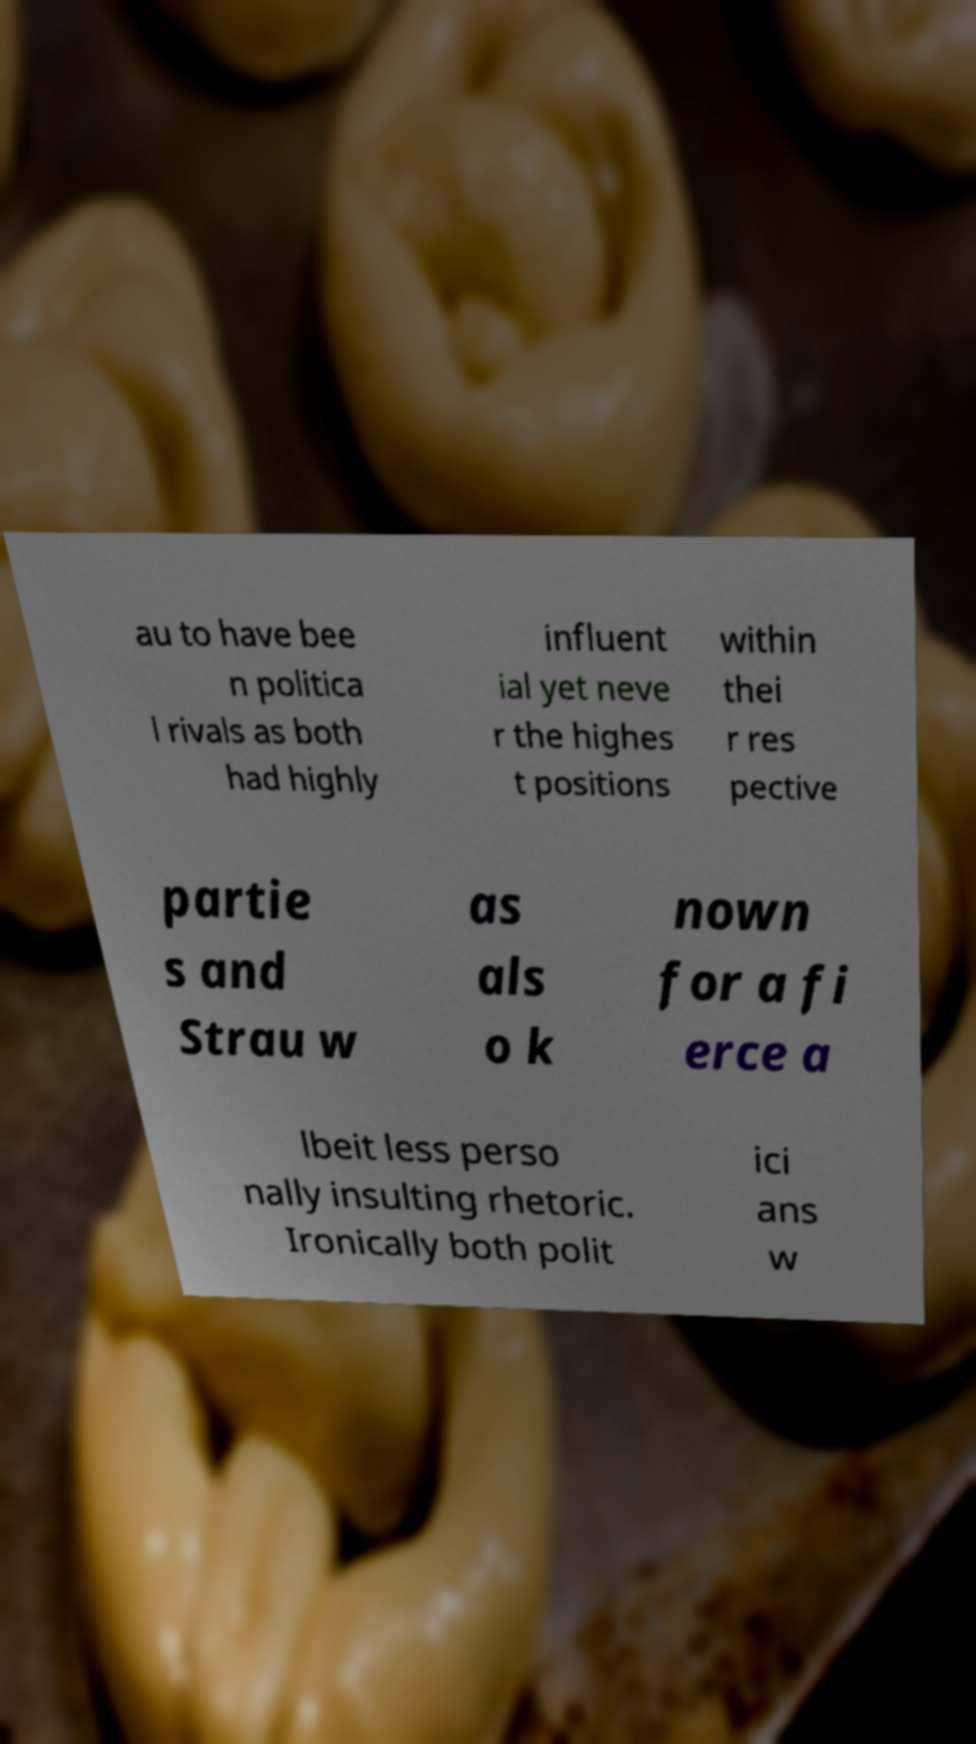There's text embedded in this image that I need extracted. Can you transcribe it verbatim? au to have bee n politica l rivals as both had highly influent ial yet neve r the highes t positions within thei r res pective partie s and Strau w as als o k nown for a fi erce a lbeit less perso nally insulting rhetoric. Ironically both polit ici ans w 